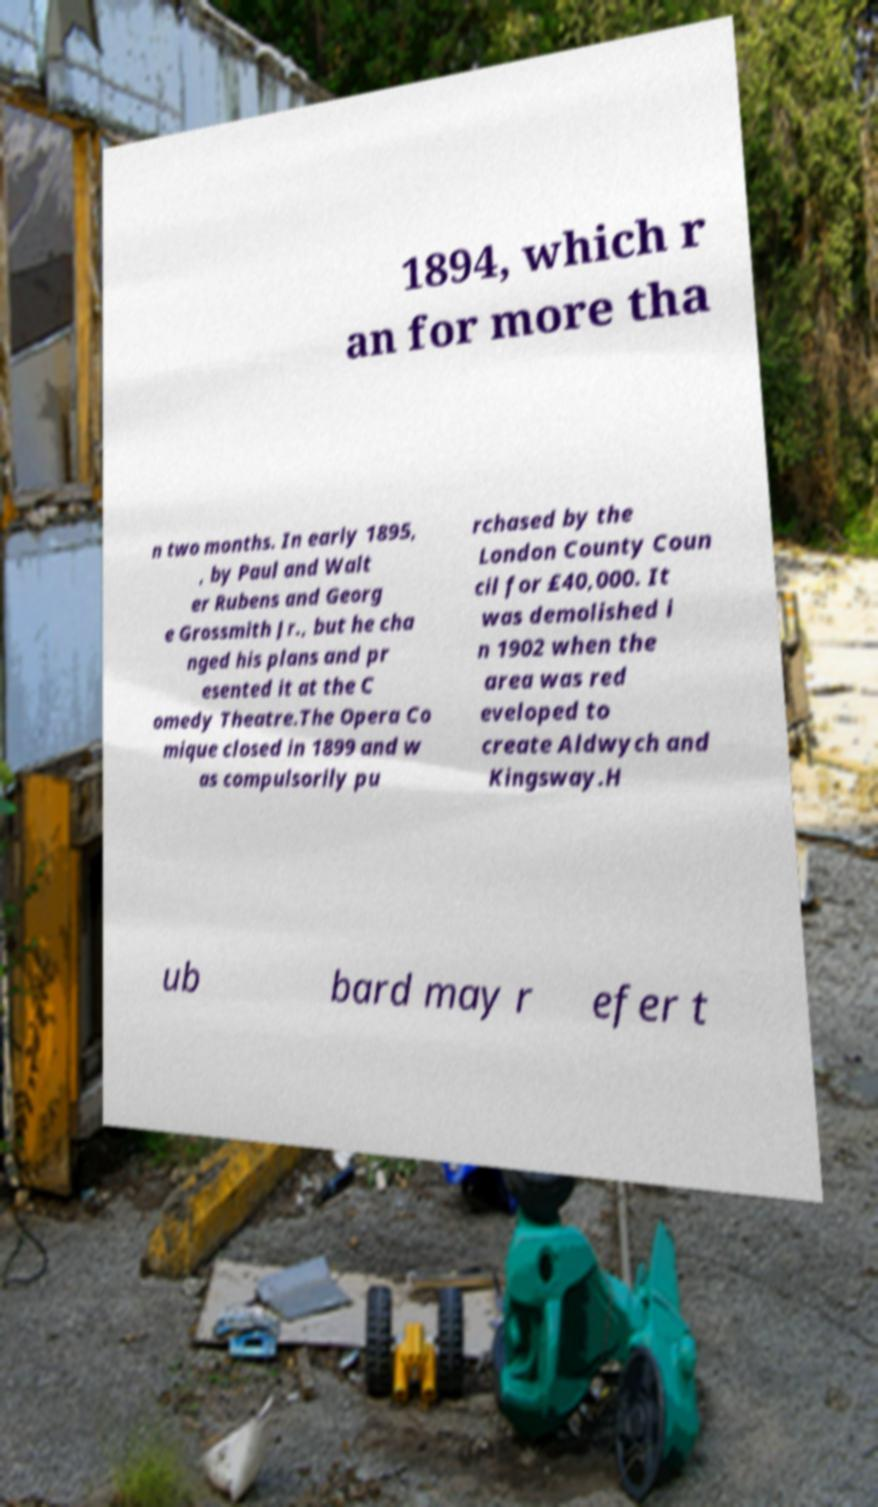Please read and relay the text visible in this image. What does it say? 1894, which r an for more tha n two months. In early 1895, , by Paul and Walt er Rubens and Georg e Grossmith Jr., but he cha nged his plans and pr esented it at the C omedy Theatre.The Opera Co mique closed in 1899 and w as compulsorily pu rchased by the London County Coun cil for £40,000. It was demolished i n 1902 when the area was red eveloped to create Aldwych and Kingsway.H ub bard may r efer t 